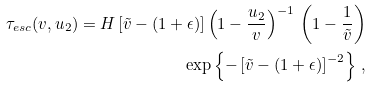<formula> <loc_0><loc_0><loc_500><loc_500>\tau _ { e s c } ( v , u _ { 2 } ) = H \left [ \tilde { v } - ( 1 + \epsilon ) \right ] \left ( 1 - \frac { u _ { 2 } } { v } \right ) ^ { - 1 } \, \left ( 1 - \frac { 1 } { \tilde { v } } \right ) \\ \exp \left \{ - \left [ \tilde { v } - ( 1 + \epsilon ) \right ] ^ { - 2 } \right \} \, ,</formula> 